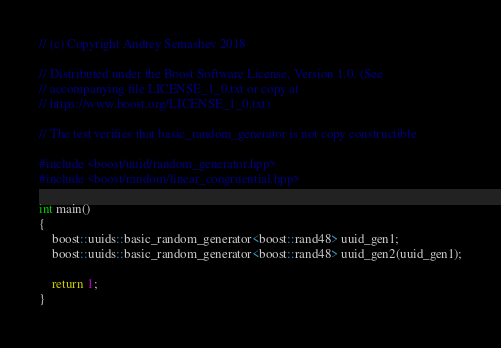<code> <loc_0><loc_0><loc_500><loc_500><_C++_>// (c) Copyright Andrey Semashev 2018

// Distributed under the Boost Software License, Version 1.0. (See
// accompanying file LICENSE_1_0.txt or copy at
// https://www.boost.org/LICENSE_1_0.txt)

// The test verifies that basic_random_generator is not copy constructible

#include <boost/uuid/random_generator.hpp>
#include <boost/random/linear_congruential.hpp>

int main()
{
    boost::uuids::basic_random_generator<boost::rand48> uuid_gen1;
    boost::uuids::basic_random_generator<boost::rand48> uuid_gen2(uuid_gen1);

    return 1;
}
</code> 